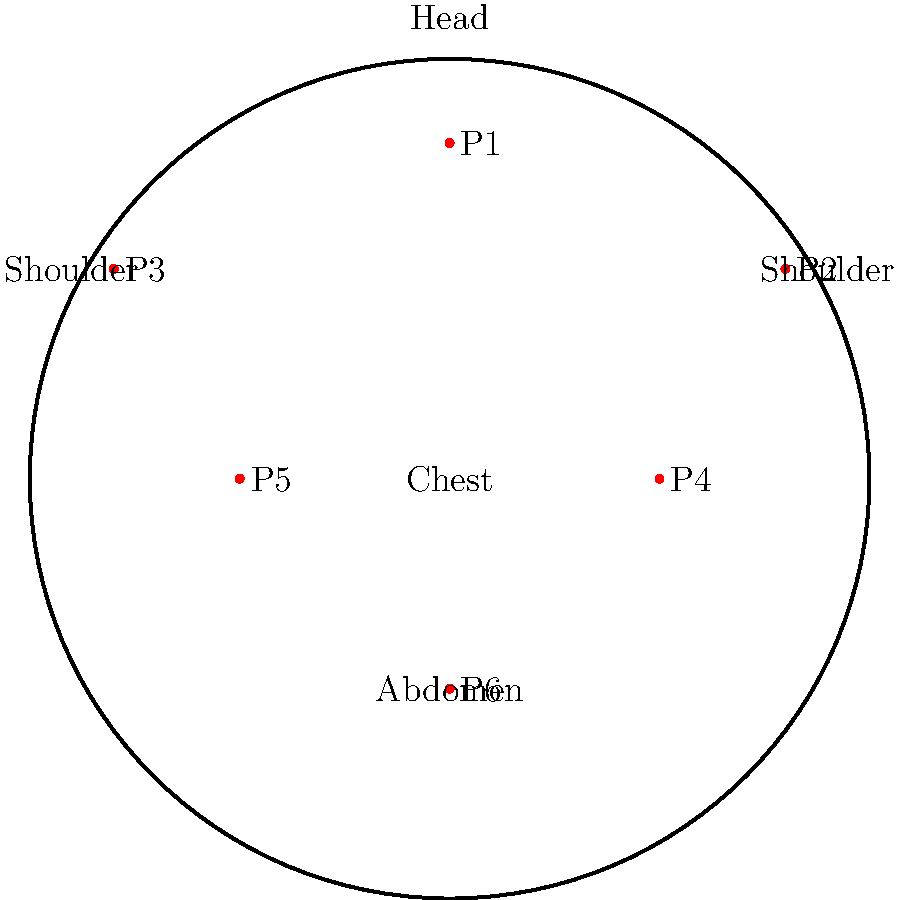In the context of martial arts applications, which pressure point on the anatomical diagram would be most effective for temporarily incapacitating an opponent by targeting the vagus nerve, potentially causing a vasovagal response? To answer this question, we need to consider the following steps:

1. Understand the vagus nerve: The vagus nerve is the tenth cranial nerve and runs from the brainstem through the neck and thorax to the abdomen.

2. Identify the vasovagal response: This is a reflex of the involuntary nervous system that can cause fainting due to a sudden drop in heart rate and blood pressure.

3. Analyze the pressure points on the diagram:
   P1: Top of the head
   P2 and P3: Sides of the neck
   P4 and P5: Upper chest area
   P6: Solar plexus region

4. Consider the anatomical location of the vagus nerve: It runs through the neck and chest.

5. Evaluate the effectiveness of targeting each point:
   - P1 is too high to affect the vagus nerve directly.
   - P4, P5, and P6 are lower than the primary path of the vagus nerve.
   - P2 and P3 are located on the sides of the neck, where the vagus nerve passes.

6. Determine the most effective point: P2 or P3 (sides of the neck) would be most effective for targeting the vagus nerve.

7. Choose one side: In martial arts, practitioners often target the right side of the neck (P2) for consistency and to avoid potential confusion in high-stress situations.

Therefore, pressure point P2 on the right side of the neck would be most effective for temporarily incapacitating an opponent by targeting the vagus nerve and potentially causing a vasovagal response.
Answer: P2 (right side of the neck) 